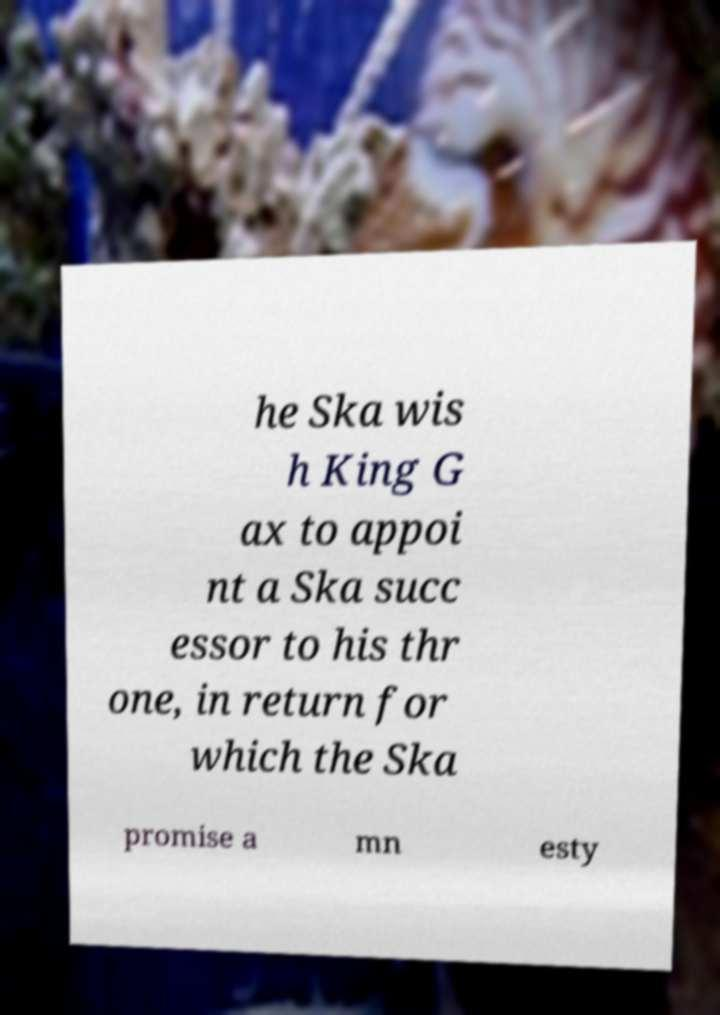There's text embedded in this image that I need extracted. Can you transcribe it verbatim? he Ska wis h King G ax to appoi nt a Ska succ essor to his thr one, in return for which the Ska promise a mn esty 